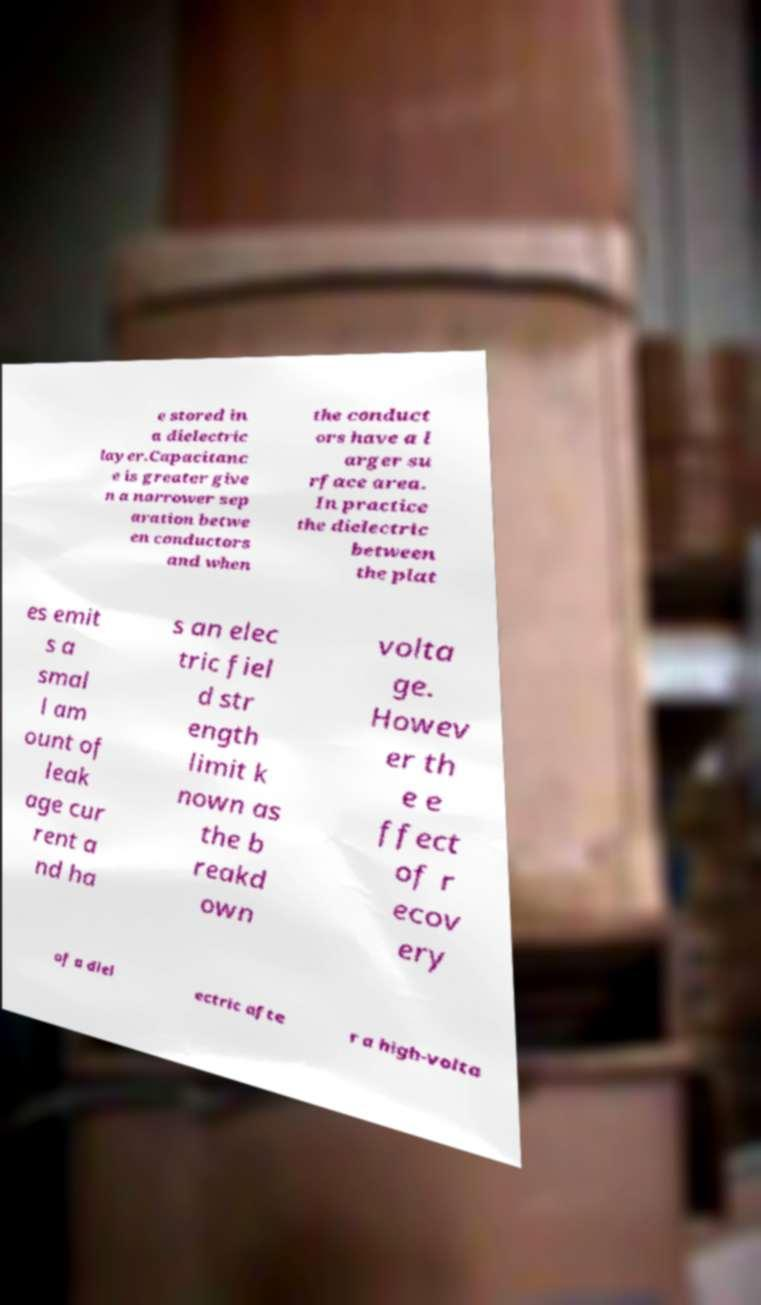Please identify and transcribe the text found in this image. e stored in a dielectric layer.Capacitanc e is greater give n a narrower sep aration betwe en conductors and when the conduct ors have a l arger su rface area. In practice the dielectric between the plat es emit s a smal l am ount of leak age cur rent a nd ha s an elec tric fiel d str ength limit k nown as the b reakd own volta ge. Howev er th e e ffect of r ecov ery of a diel ectric afte r a high-volta 